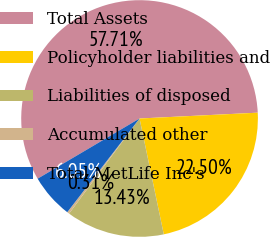<chart> <loc_0><loc_0><loc_500><loc_500><pie_chart><fcel>Total Assets<fcel>Policyholder liabilities and<fcel>Liabilities of disposed<fcel>Accumulated other<fcel>Total MetLife Inc's<nl><fcel>57.7%<fcel>22.5%<fcel>13.43%<fcel>0.31%<fcel>6.05%<nl></chart> 